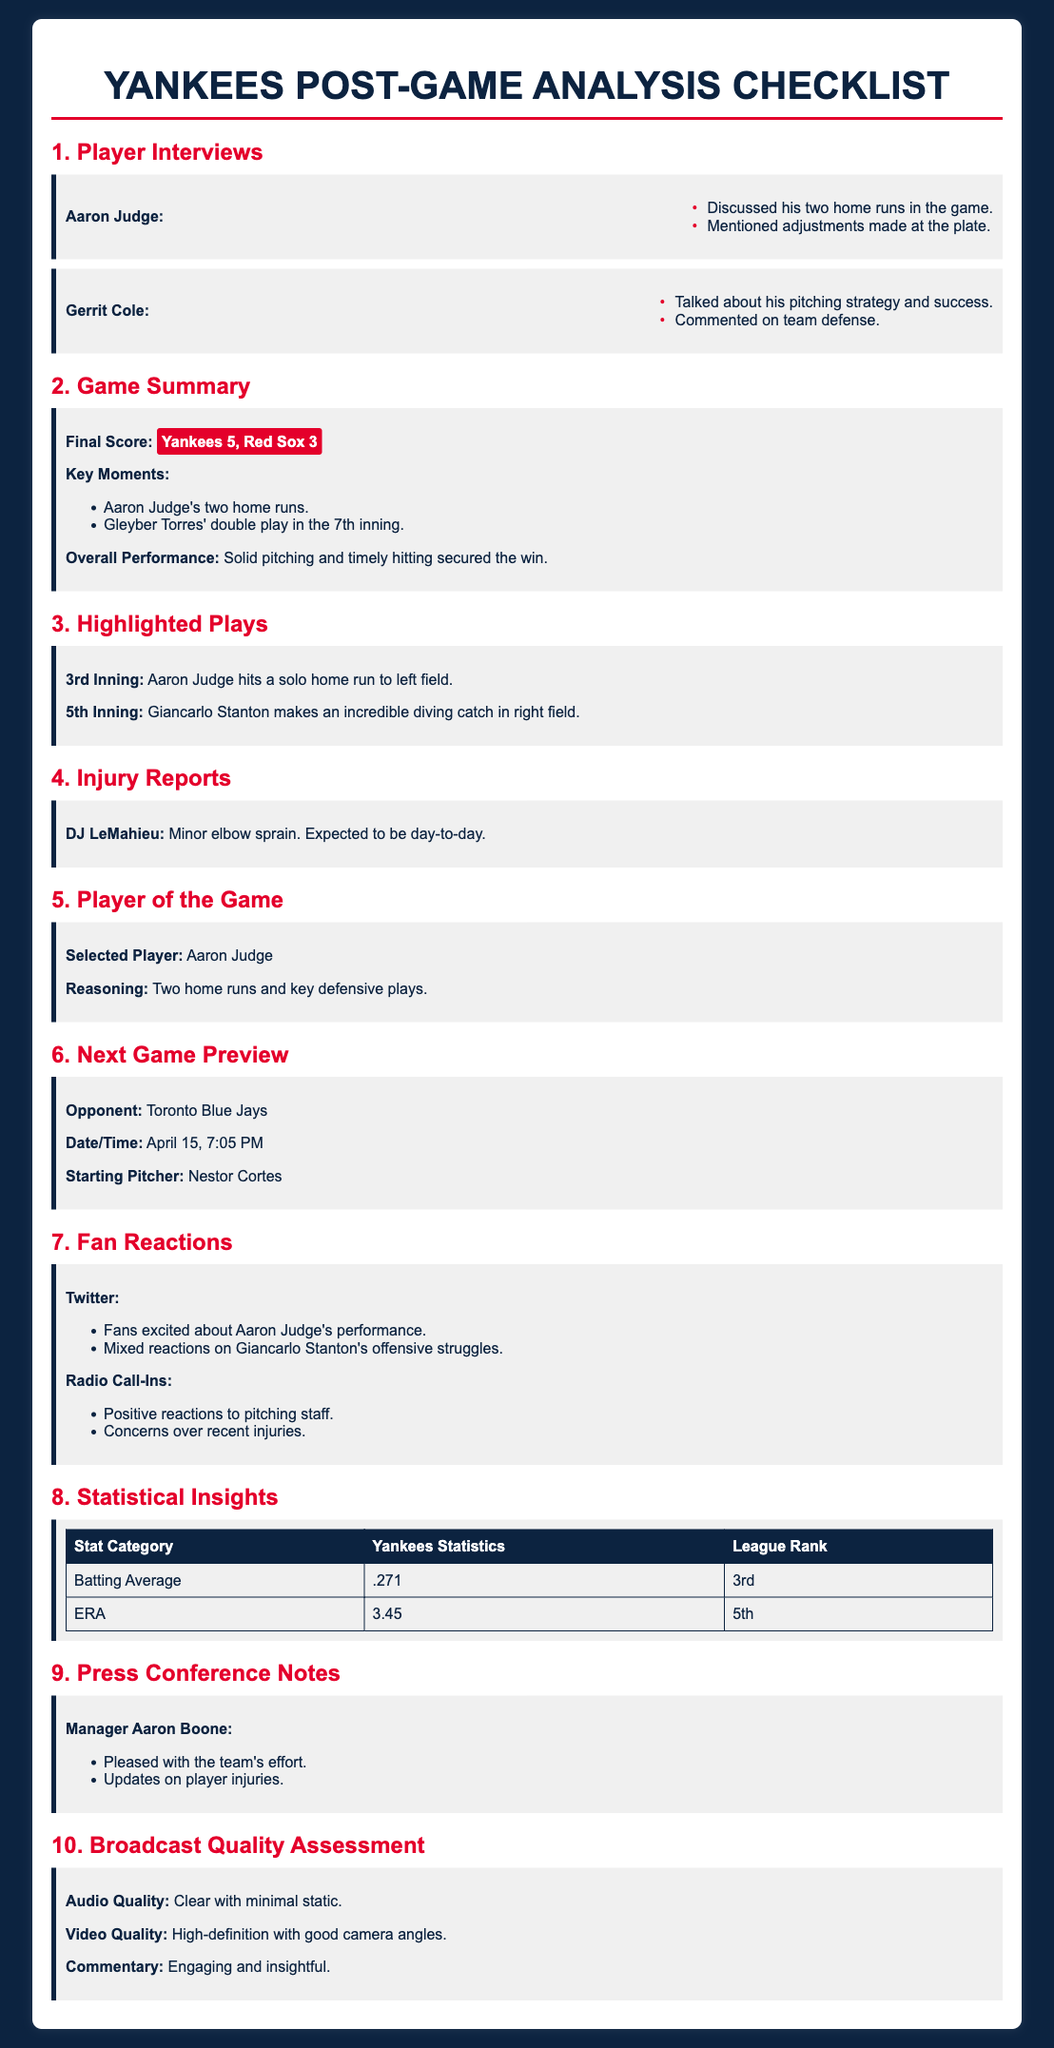what was the final score of the game? The final score is provided in the game summary section of the document, which states that the Yankees won against the Red Sox.
Answer: Yankees 5, Red Sox 3 who was selected as Player of the Game? The Player of the Game is specified in the corresponding section of the checklist.
Answer: Aaron Judge what injury was reported for DJ LeMahieu? The injury details can be found in the injury reports section that mentions specific injuries affecting players.
Answer: Minor elbow sprain what time is the next game scheduled? The time for the next game is found in the next game preview section of the document.
Answer: 7:05 PM which inning did Aaron Judge hit a home run? The highlighted play section provides information about specific plays during the game, including the inning of Judge's home run.
Answer: 3rd Inning what key point did Gerrit Cole mention in his interview? Key points from player interviews are summarized in the checklist for each player, focusing on their performance and thoughts.
Answer: Pitching strategy and success how did fans react to Giancarlo Stanton's performance? Fan reactions regarding players’ performances can be found in the fan reactions section of the checklist.
Answer: Mixed reactions what is the Yankees' batting average? The statistical insights section lists player statistics and their corresponding league ranks.
Answer: .271 who is the starting pitcher for the next game? Information about the next game and players is present in the next game preview section.
Answer: Nestor Cortes 